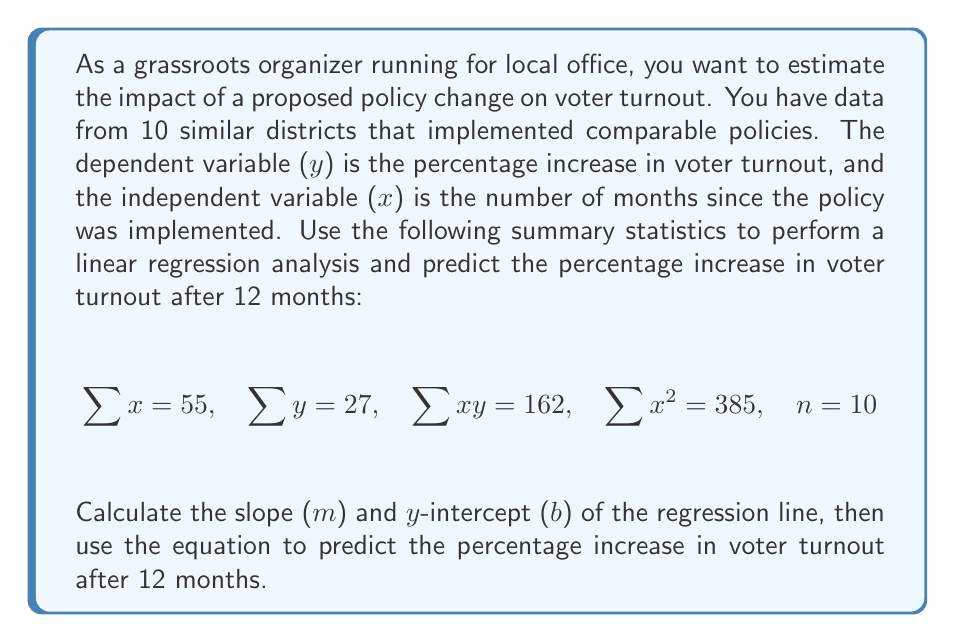What is the answer to this math problem? To solve this problem, we'll use the least squares regression method to find the slope (m) and y-intercept (b) of the line of best fit. Then we'll use the resulting equation to make our prediction.

Step 1: Calculate the slope (m) using the formula:
$$m = \frac{n\sum xy - \sum x \sum y}{n\sum x^2 - (\sum x)^2}$$

Plugging in the given values:
$$m = \frac{10(162) - 55(27)}{10(385) - 55^2}$$
$$m = \frac{1620 - 1485}{3850 - 3025}$$
$$m = \frac{135}{825} = \frac{27}{165} \approx 0.1636$$

Step 2: Calculate the y-intercept (b) using the formula:
$$b = \frac{\sum y - m\sum x}{n}$$

Plugging in the values:
$$b = \frac{27 - 0.1636(55)}{10}$$
$$b = \frac{27 - 9}{10} = \frac{18}{10} = 1.8$$

Step 3: Write the equation of the regression line:
$$y = mx + b$$
$$y = 0.1636x + 1.8$$

Step 4: Use the equation to predict the percentage increase in voter turnout after 12 months:
$$y = 0.1636(12) + 1.8$$
$$y = 1.9632 + 1.8$$
$$y = 3.7632$$

Therefore, the predicted percentage increase in voter turnout after 12 months is approximately 3.76%.
Answer: 3.76% 